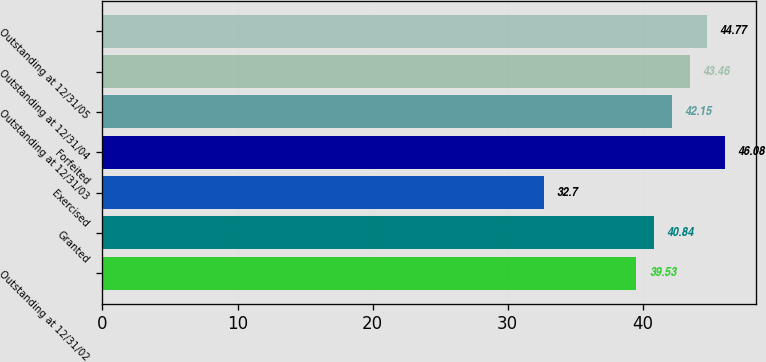Convert chart. <chart><loc_0><loc_0><loc_500><loc_500><bar_chart><fcel>Outstanding at 12/31/02<fcel>Granted<fcel>Exercised<fcel>Forfeited<fcel>Outstanding at 12/31/03<fcel>Outstanding at 12/31/04<fcel>Outstanding at 12/31/05<nl><fcel>39.53<fcel>40.84<fcel>32.7<fcel>46.08<fcel>42.15<fcel>43.46<fcel>44.77<nl></chart> 